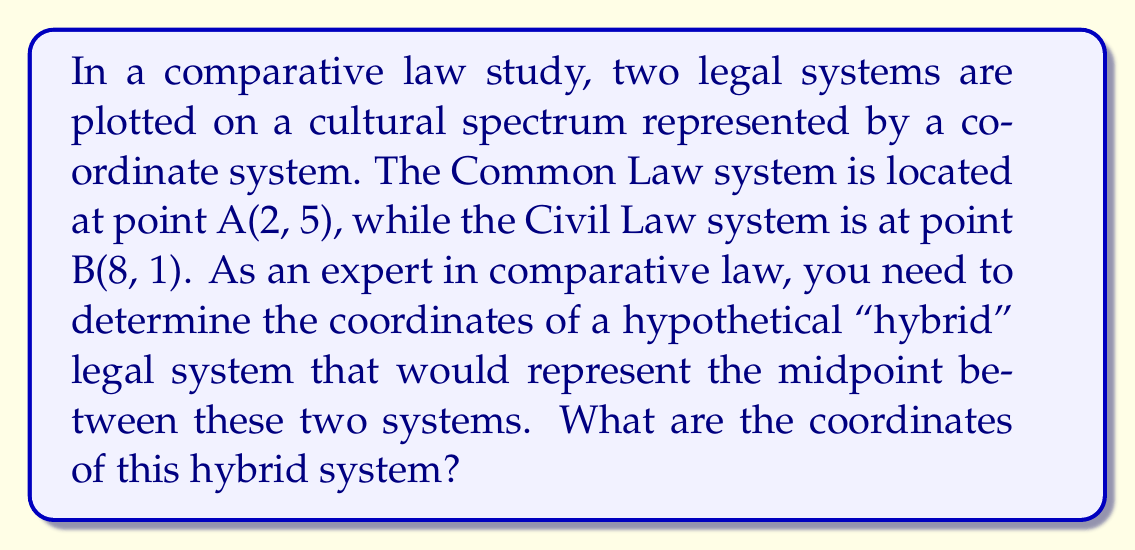Can you answer this question? To solve this problem, we need to apply the midpoint formula in a two-dimensional coordinate system. The midpoint formula is:

$$\left(\frac{x_1 + x_2}{2}, \frac{y_1 + y_2}{2}\right)$$

Where $(x_1, y_1)$ are the coordinates of the first point and $(x_2, y_2)$ are the coordinates of the second point.

Given:
- Common Law system (Point A): $(2, 5)$
- Civil Law system (Point B): $(8, 1)$

Let's apply the midpoint formula:

1. For the x-coordinate:
   $$\frac{x_1 + x_2}{2} = \frac{2 + 8}{2} = \frac{10}{2} = 5$$

2. For the y-coordinate:
   $$\frac{y_1 + y_2}{2} = \frac{5 + 1}{2} = \frac{6}{2} = 3$$

Therefore, the coordinates of the hybrid system (midpoint) are $(5, 3)$.

This point represents a legal system that would theoretically balance elements from both Common Law and Civil Law traditions, potentially incorporating aspects such as statutory law interpretation, precedent consideration, and codification practices from both systems.
Answer: $(5, 3)$ 